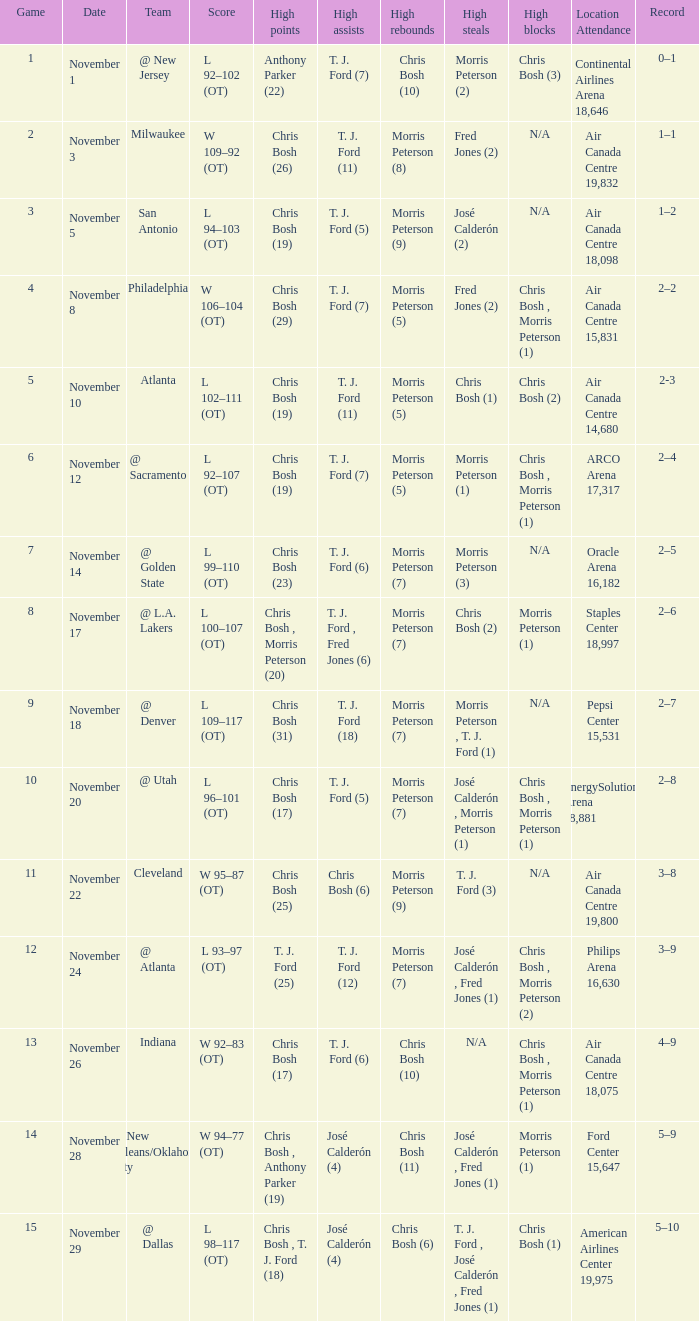What team played on November 28? @ New Orleans/Oklahoma City. 